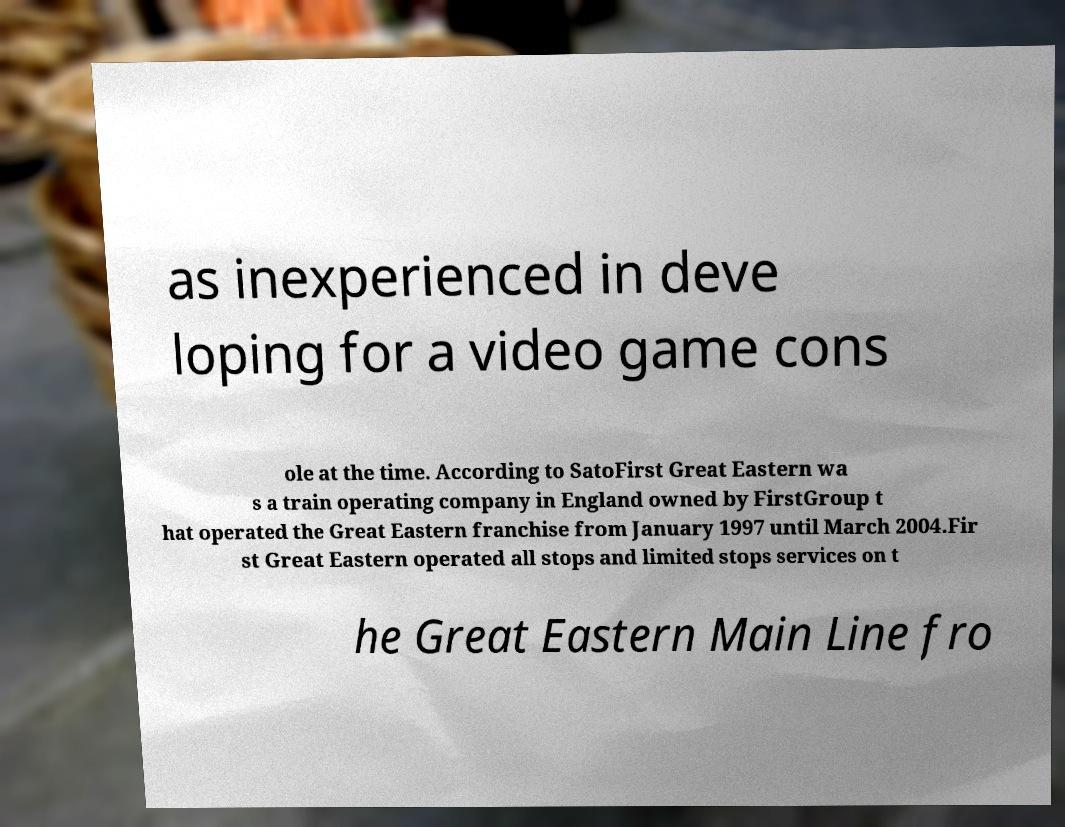Can you accurately transcribe the text from the provided image for me? as inexperienced in deve loping for a video game cons ole at the time. According to SatoFirst Great Eastern wa s a train operating company in England owned by FirstGroup t hat operated the Great Eastern franchise from January 1997 until March 2004.Fir st Great Eastern operated all stops and limited stops services on t he Great Eastern Main Line fro 